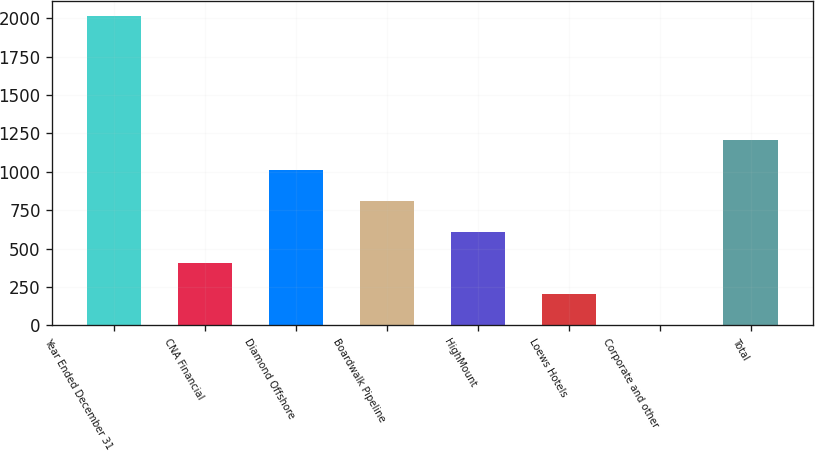Convert chart. <chart><loc_0><loc_0><loc_500><loc_500><bar_chart><fcel>Year Ended December 31<fcel>CNA Financial<fcel>Diamond Offshore<fcel>Boardwalk Pipeline<fcel>HighMount<fcel>Loews Hotels<fcel>Corporate and other<fcel>Total<nl><fcel>2013<fcel>407.4<fcel>1009.5<fcel>808.8<fcel>608.1<fcel>206.7<fcel>6<fcel>1210.2<nl></chart> 